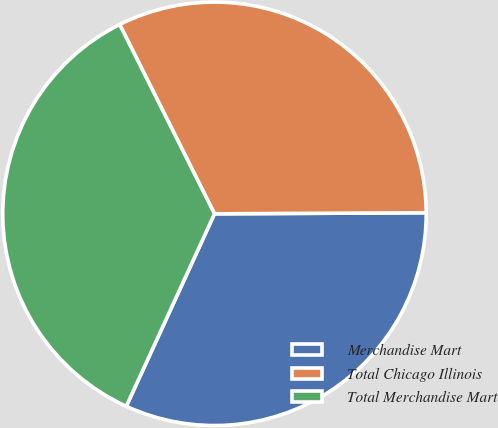Convert chart. <chart><loc_0><loc_0><loc_500><loc_500><pie_chart><fcel>Merchandise Mart<fcel>Total Chicago Illinois<fcel>Total Merchandise Mart<nl><fcel>31.92%<fcel>32.31%<fcel>35.77%<nl></chart> 